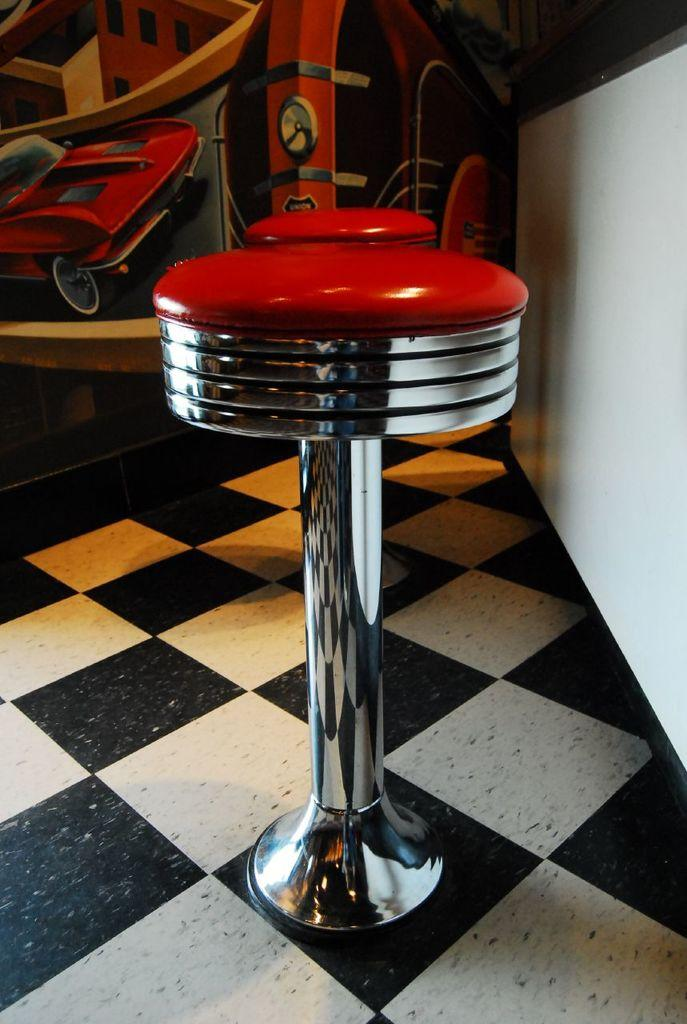What type of seating is present in the image? There are fancy chairs in the image. Where are the chairs located? The chairs are on the floor. What can be seen on the wall in the image? There are posters on the wall in the image. What type of coach is visible in the image? There is no coach present in the image. What type of frame is holding the posters on the wall? The provided facts do not mention any frames holding the posters on the wall. 